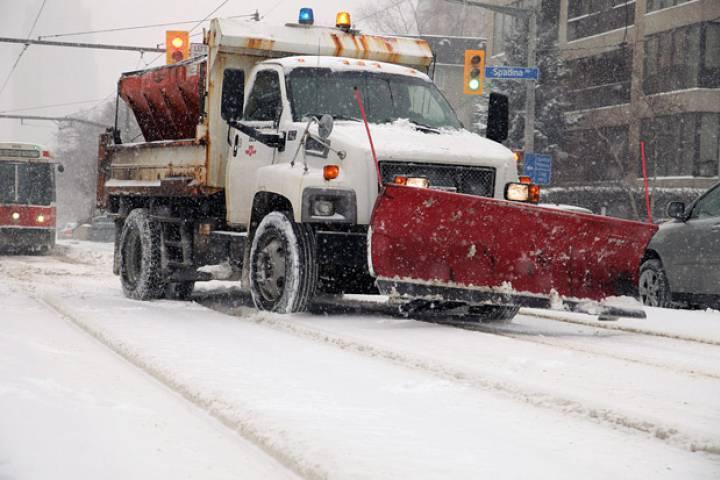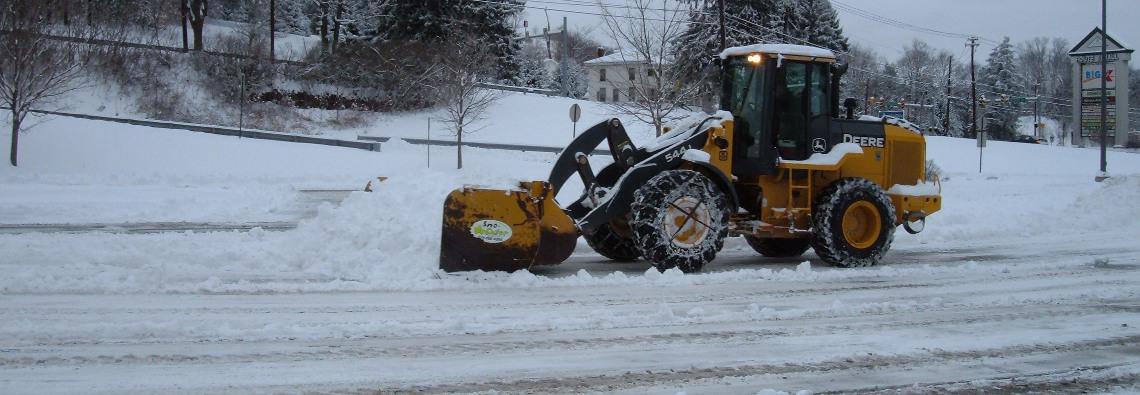The first image is the image on the left, the second image is the image on the right. For the images displayed, is the sentence "There is a snow plow attached to a truck in the left image and a different heavy machinery vehicle in the right image." factually correct? Answer yes or no. Yes. The first image is the image on the left, the second image is the image on the right. Evaluate the accuracy of this statement regarding the images: "The truck in one of the images has a red plow.". Is it true? Answer yes or no. Yes. 